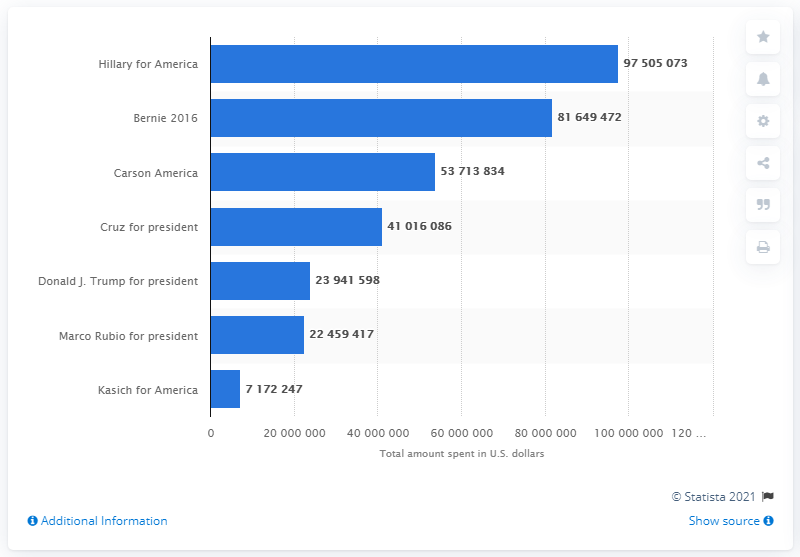Give some essential details in this illustration. In total, Hillary for America spent $9,750,507.30 on their election campaign. 